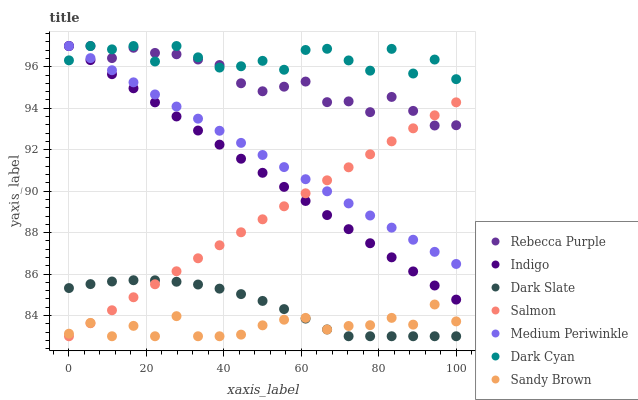Does Sandy Brown have the minimum area under the curve?
Answer yes or no. Yes. Does Dark Cyan have the maximum area under the curve?
Answer yes or no. Yes. Does Salmon have the minimum area under the curve?
Answer yes or no. No. Does Salmon have the maximum area under the curve?
Answer yes or no. No. Is Medium Periwinkle the smoothest?
Answer yes or no. Yes. Is Dark Cyan the roughest?
Answer yes or no. Yes. Is Salmon the smoothest?
Answer yes or no. No. Is Salmon the roughest?
Answer yes or no. No. Does Salmon have the lowest value?
Answer yes or no. Yes. Does Medium Periwinkle have the lowest value?
Answer yes or no. No. Does Dark Cyan have the highest value?
Answer yes or no. Yes. Does Salmon have the highest value?
Answer yes or no. No. Is Dark Slate less than Rebecca Purple?
Answer yes or no. Yes. Is Dark Cyan greater than Dark Slate?
Answer yes or no. Yes. Does Rebecca Purple intersect Indigo?
Answer yes or no. Yes. Is Rebecca Purple less than Indigo?
Answer yes or no. No. Is Rebecca Purple greater than Indigo?
Answer yes or no. No. Does Dark Slate intersect Rebecca Purple?
Answer yes or no. No. 